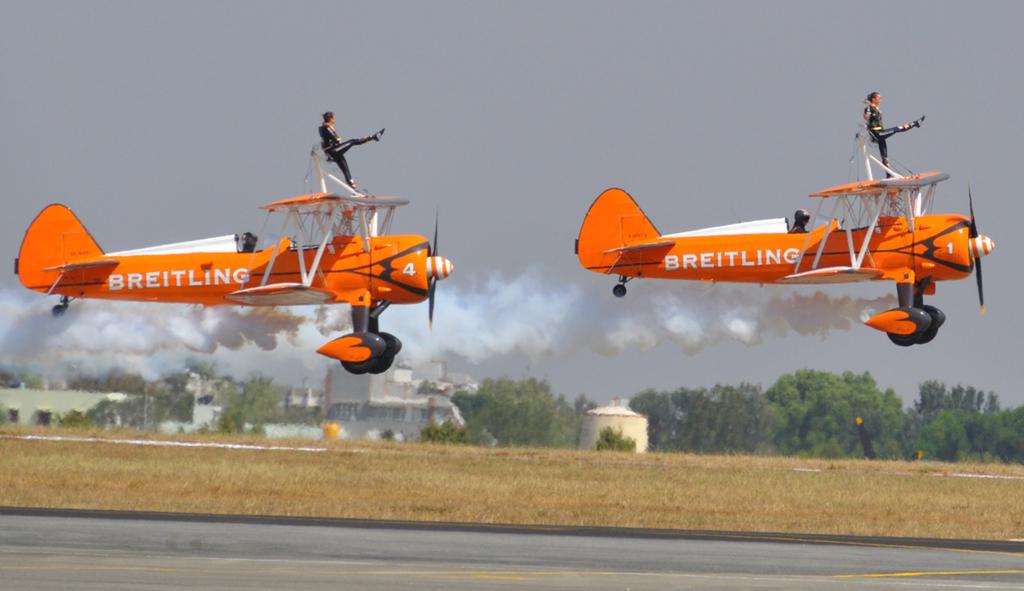What airline of planes are these?
Make the answer very short. Breitling. What number is the plane in the back?
Ensure brevity in your answer.  4. 